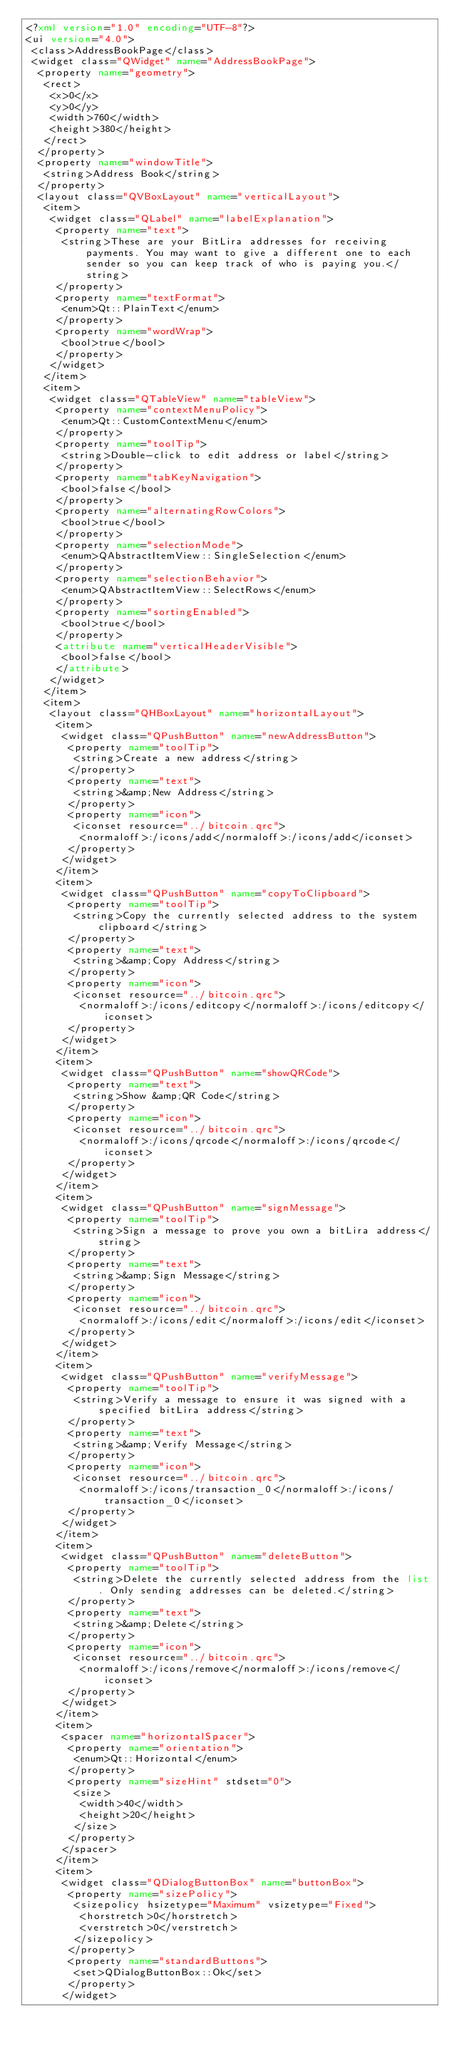Convert code to text. <code><loc_0><loc_0><loc_500><loc_500><_XML_><?xml version="1.0" encoding="UTF-8"?>
<ui version="4.0">
 <class>AddressBookPage</class>
 <widget class="QWidget" name="AddressBookPage">
  <property name="geometry">
   <rect>
    <x>0</x>
    <y>0</y>
    <width>760</width>
    <height>380</height>
   </rect>
  </property>
  <property name="windowTitle">
   <string>Address Book</string>
  </property>
  <layout class="QVBoxLayout" name="verticalLayout">
   <item>
    <widget class="QLabel" name="labelExplanation">
     <property name="text">
      <string>These are your BitLira addresses for receiving payments. You may want to give a different one to each sender so you can keep track of who is paying you.</string>
     </property>
     <property name="textFormat">
      <enum>Qt::PlainText</enum>
     </property>
     <property name="wordWrap">
      <bool>true</bool>
     </property>
    </widget>
   </item>
   <item>
    <widget class="QTableView" name="tableView">
     <property name="contextMenuPolicy">
      <enum>Qt::CustomContextMenu</enum>
     </property>
     <property name="toolTip">
      <string>Double-click to edit address or label</string>
     </property>
     <property name="tabKeyNavigation">
      <bool>false</bool>
     </property>
     <property name="alternatingRowColors">
      <bool>true</bool>
     </property>
     <property name="selectionMode">
      <enum>QAbstractItemView::SingleSelection</enum>
     </property>
     <property name="selectionBehavior">
      <enum>QAbstractItemView::SelectRows</enum>
     </property>
     <property name="sortingEnabled">
      <bool>true</bool>
     </property>
     <attribute name="verticalHeaderVisible">
      <bool>false</bool>
     </attribute>
    </widget>
   </item>
   <item>
    <layout class="QHBoxLayout" name="horizontalLayout">
     <item>
      <widget class="QPushButton" name="newAddressButton">
       <property name="toolTip">
        <string>Create a new address</string>
       </property>
       <property name="text">
        <string>&amp;New Address</string>
       </property>
       <property name="icon">
        <iconset resource="../bitcoin.qrc">
         <normaloff>:/icons/add</normaloff>:/icons/add</iconset>
       </property>
      </widget>
     </item>
     <item>
      <widget class="QPushButton" name="copyToClipboard">
       <property name="toolTip">
        <string>Copy the currently selected address to the system clipboard</string>
       </property>
       <property name="text">
        <string>&amp;Copy Address</string>
       </property>
       <property name="icon">
        <iconset resource="../bitcoin.qrc">
         <normaloff>:/icons/editcopy</normaloff>:/icons/editcopy</iconset>
       </property>
      </widget>
     </item>
     <item>
      <widget class="QPushButton" name="showQRCode">
       <property name="text">
        <string>Show &amp;QR Code</string>
       </property>
       <property name="icon">
        <iconset resource="../bitcoin.qrc">
         <normaloff>:/icons/qrcode</normaloff>:/icons/qrcode</iconset>
       </property>
      </widget>
     </item>
     <item>
      <widget class="QPushButton" name="signMessage">
       <property name="toolTip">
        <string>Sign a message to prove you own a bitLira address</string>
       </property>
       <property name="text">
        <string>&amp;Sign Message</string>
       </property>
       <property name="icon">
        <iconset resource="../bitcoin.qrc">
         <normaloff>:/icons/edit</normaloff>:/icons/edit</iconset>
       </property>
      </widget>
     </item>
     <item>
      <widget class="QPushButton" name="verifyMessage">
       <property name="toolTip">
        <string>Verify a message to ensure it was signed with a specified bitLira address</string>
       </property>
       <property name="text">
        <string>&amp;Verify Message</string>
       </property>
       <property name="icon">
        <iconset resource="../bitcoin.qrc">
         <normaloff>:/icons/transaction_0</normaloff>:/icons/transaction_0</iconset>
       </property>
      </widget>
     </item>
     <item>
      <widget class="QPushButton" name="deleteButton">
       <property name="toolTip">
        <string>Delete the currently selected address from the list. Only sending addresses can be deleted.</string>
       </property>
       <property name="text">
        <string>&amp;Delete</string>
       </property>
       <property name="icon">
        <iconset resource="../bitcoin.qrc">
         <normaloff>:/icons/remove</normaloff>:/icons/remove</iconset>
       </property>
      </widget>
     </item>
     <item>
      <spacer name="horizontalSpacer">
       <property name="orientation">
        <enum>Qt::Horizontal</enum>
       </property>
       <property name="sizeHint" stdset="0">
        <size>
         <width>40</width>
         <height>20</height>
        </size>
       </property>
      </spacer>
     </item>
     <item>
      <widget class="QDialogButtonBox" name="buttonBox">
       <property name="sizePolicy">
        <sizepolicy hsizetype="Maximum" vsizetype="Fixed">
         <horstretch>0</horstretch>
         <verstretch>0</verstretch>
        </sizepolicy>
       </property>
       <property name="standardButtons">
        <set>QDialogButtonBox::Ok</set>
       </property>
      </widget></code> 